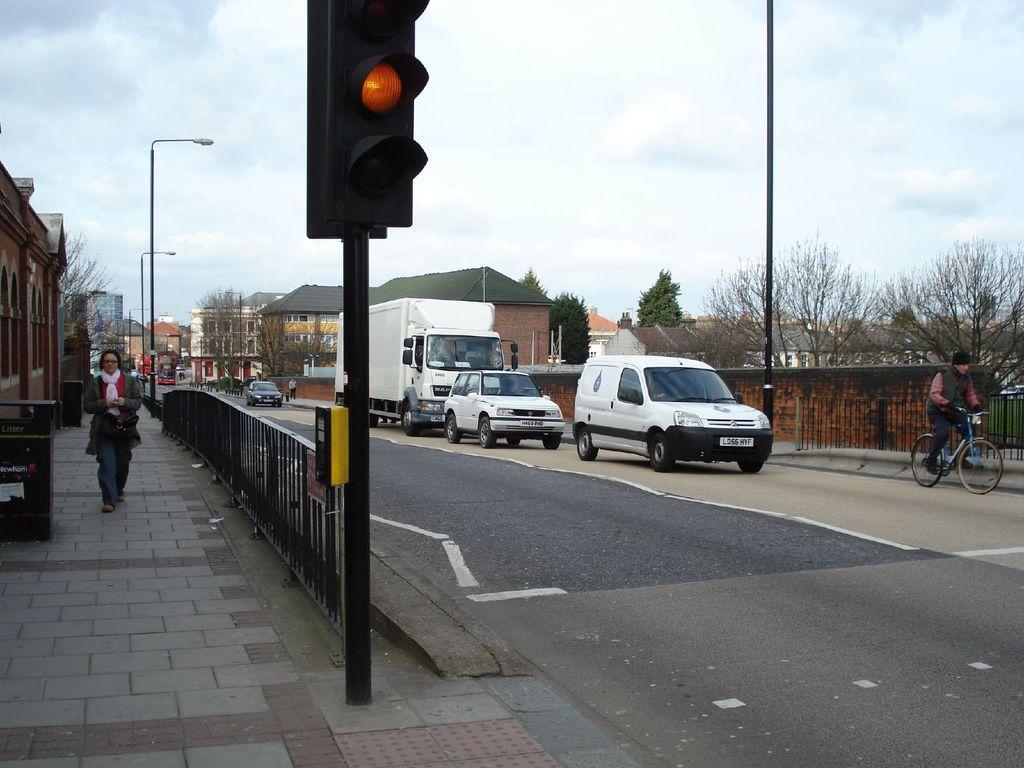Could you give a brief overview of what you see in this image? This is an outside view. On the right side there are few vehicles on the road and a person is riding the bicycle. On the left side there is a person walking on the footpath. Beside there is a railing. In the background there are many trees, houses and light poles. At the top of the image I can see the sky and clouds. In the foreground there is a traffic signal pole beside the road. 